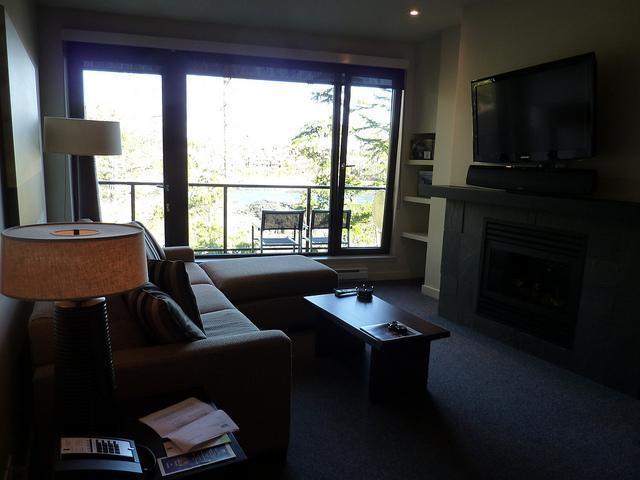How many lamps are in this room?
Give a very brief answer. 2. How many pillows are on the sofa?
Give a very brief answer. 2. How many books can you see?
Give a very brief answer. 1. How many tvs can be seen?
Give a very brief answer. 1. How many couches are there?
Give a very brief answer. 2. How many people are wearing glasses?
Give a very brief answer. 0. 